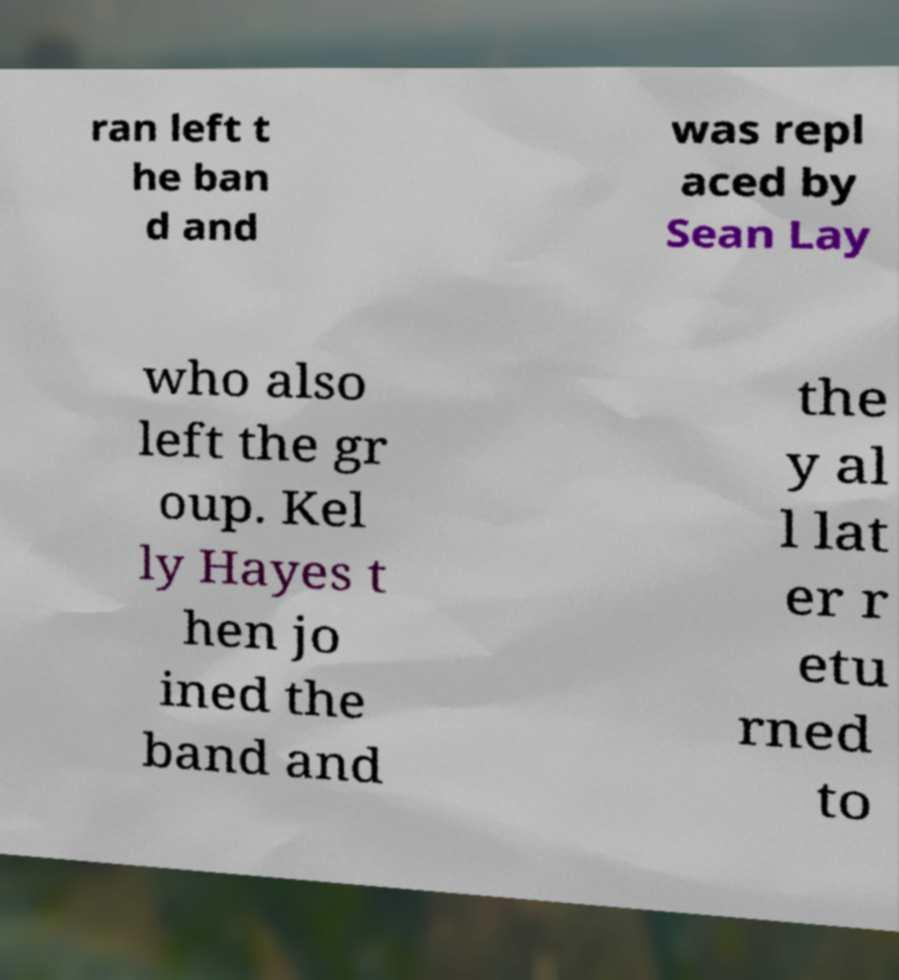Could you extract and type out the text from this image? ran left t he ban d and was repl aced by Sean Lay who also left the gr oup. Kel ly Hayes t hen jo ined the band and the y al l lat er r etu rned to 